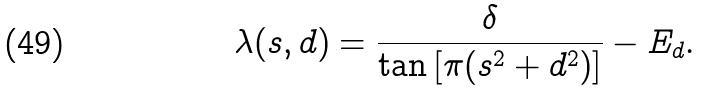Convert formula to latex. <formula><loc_0><loc_0><loc_500><loc_500>\lambda ( s , d ) = \frac { \delta } { \tan { \left [ \pi ( s ^ { 2 } + d ^ { 2 } ) \right ] } } - E _ { d } .</formula> 